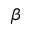<formula> <loc_0><loc_0><loc_500><loc_500>\beta</formula> 